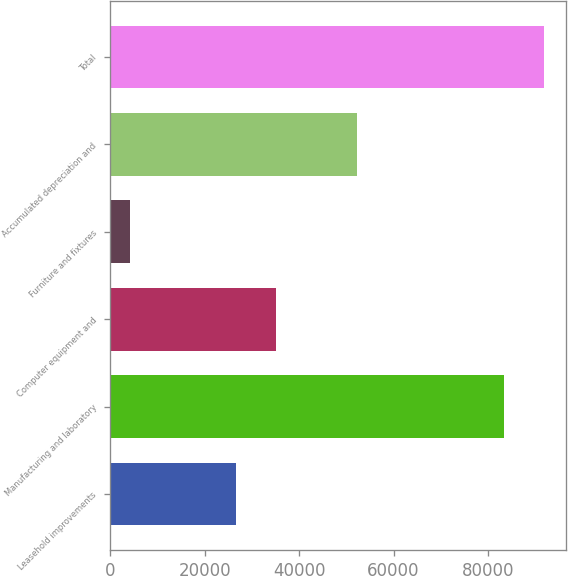Convert chart. <chart><loc_0><loc_0><loc_500><loc_500><bar_chart><fcel>Leasehold improvements<fcel>Manufacturing and laboratory<fcel>Computer equipment and<fcel>Furniture and fixtures<fcel>Accumulated depreciation and<fcel>Total<nl><fcel>26637<fcel>83317<fcel>35163.9<fcel>4167<fcel>52175<fcel>91843.9<nl></chart> 